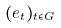<formula> <loc_0><loc_0><loc_500><loc_500>( e _ { t } ) _ { t \in G }</formula> 